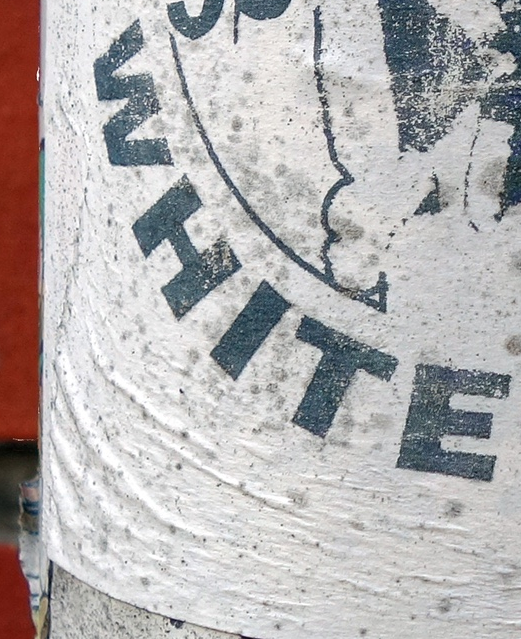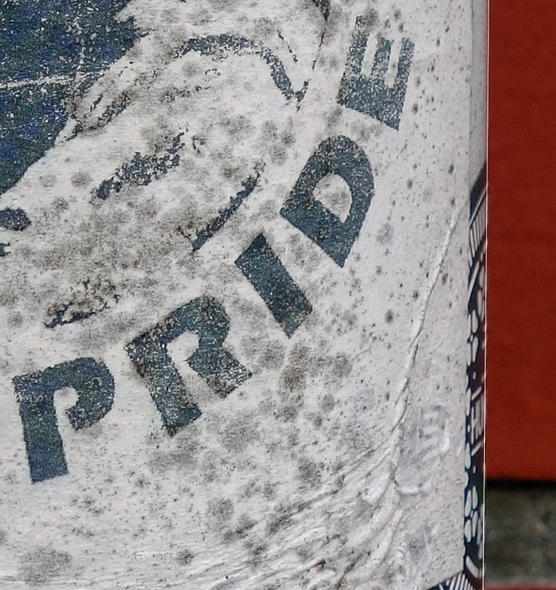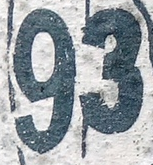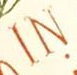Transcribe the words shown in these images in order, separated by a semicolon. WHITE; PRIDE; 93; IN 